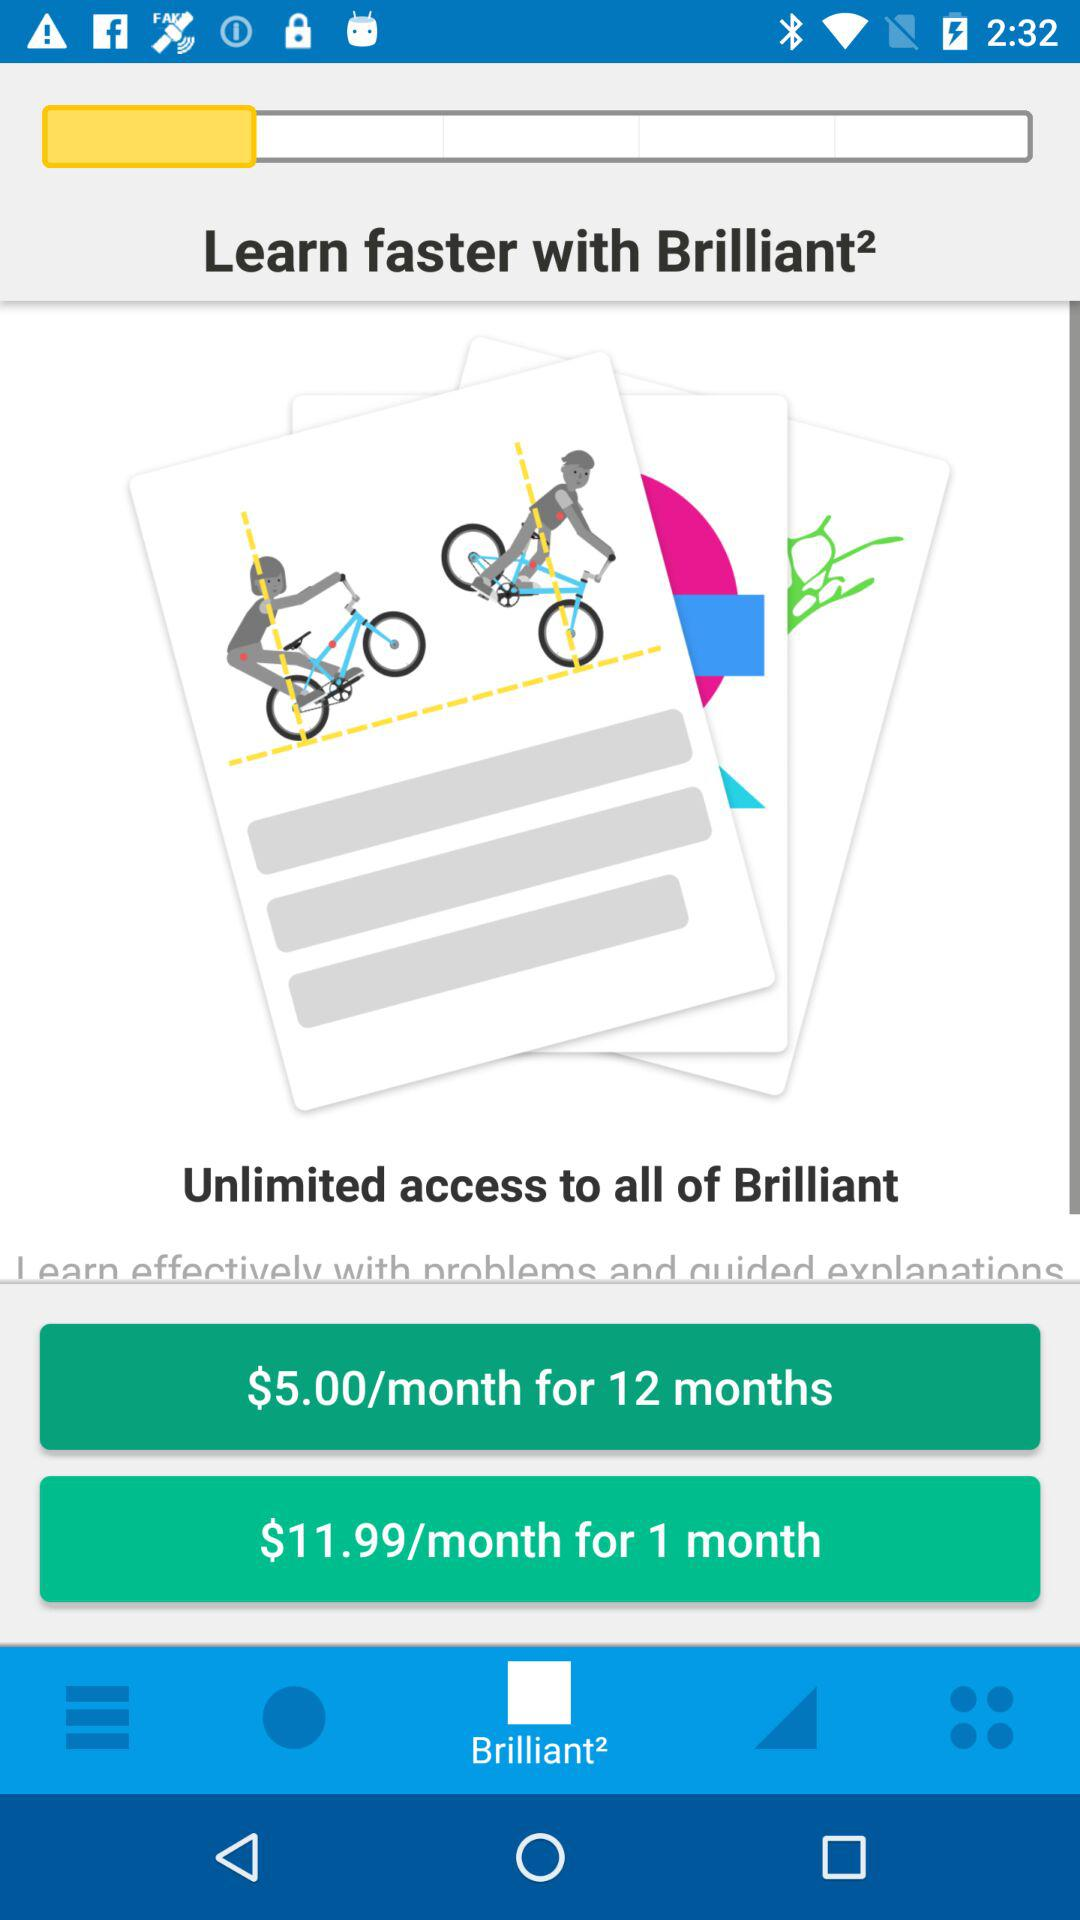How much does the 1-month subscription cost per month? The 1-month subscription costs $11.99 per month. 